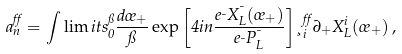Convert formula to latex. <formula><loc_0><loc_0><loc_500><loc_500>a ^ { \alpha } _ { n } = \int \lim i t s _ { 0 } ^ { \pi } \frac { d \sigma _ { + } } { \pi } \exp \left [ 4 i n \frac { e _ { \mu } X ^ { \mu } _ { L } ( \sigma _ { + } ) } { e _ { \mu } P ^ { \mu } _ { L } } \right ] \xi ^ { \alpha } _ { i } \partial _ { + } X ^ { i } _ { L } ( \sigma _ { + } ) \, ,</formula> 